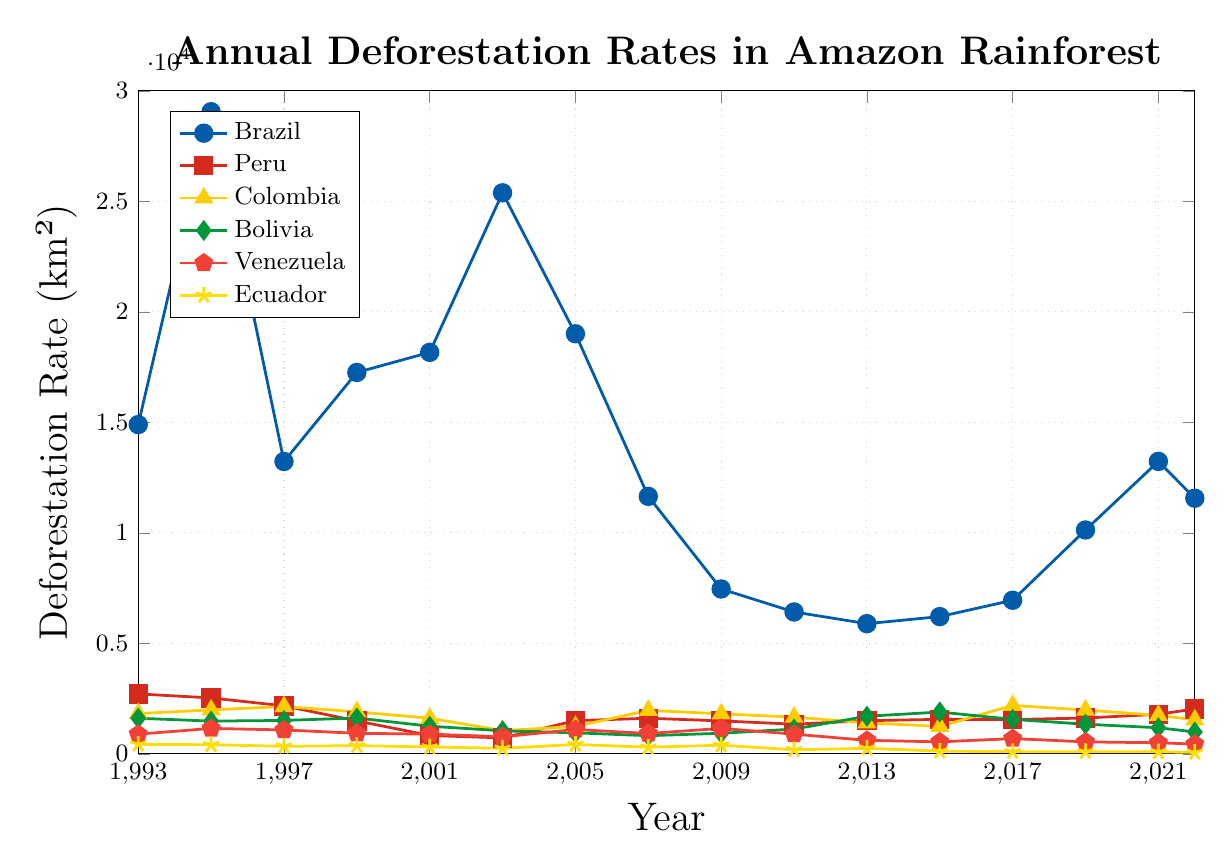Which country had the highest deforestation rate in 2003? Look at the data points for 2003 and compare them. Brazil has the highest deforestation rate, which is above 25000 km².
Answer: Brazil Which years did Brazil have a higher deforestation rate than 20000 km²? Examine the Brazil data points and pick the years where deforestation is greater than 20000 km². These years are 1995, 2003, and 2005.
Answer: 1995, 2003, 2005 What is the average deforestation rate in Peru from 1993 to 2022? Sum the deforestation rates in Peru for all the years and then divide by the number of years. Total sum: 26960. Number of years: 16. Average = 26960 / 16.
Answer: 1685 Which country experienced the most significant decrease in deforestation rate between 1995 and 2022? Check the data points for each country in 1995 and 2022 and calculate the decrease. Ecuador decreased from 410 km² in 1995 to 62 km² in 2022, the most significant drop by 348 km².
Answer: Ecuador In which year did Colombia's deforestation rate peak? Look at the Colombia data points and identify the year with the highest value. The peak is at 2190 km² in 2017.
Answer: 2017 Compare the deforestation rates of Venezuela and Ecuador in 2011. Which country had a lower rate? Refer to the data points of Venezuela and Ecuador in 2011. Venezuela has 890 km² and Ecuador has 180 km², so Ecuador has a lower rate.
Answer: Ecuador Considering the data of Peru, did its deforestation rate ever increase two consecutive measurement periods? Observe the trend of Peru data points, marking two consecutive increases. Peru showed increases in 1999-2001 (830 to 720) and 2013-2015 (1500 to 1560).
Answer: Yes Which country had the smallest fluctuation in deforestation rate over the period, considering the visual plot? Observe the consistency of the lines. Ecuador shows the smallest fluctuations, maintaining relatively low and stable rates across the years.
Answer: Ecuador What is the combined deforestation rate of Bolivia and Venezuela in 2017? Add together the deforestation rates of Bolivia and Venezuela for 2017. Bolivia: 1560, Venezuela: 690. Total is 1560 + 690.
Answer: 2250 Identify the trend of deforestation rate in Brazil from 2005 to 2022. Is it generally increasing, decreasing, or fluctuating? Look at the Brazil data points from 2005 to 2022. There is a general decreasing trend until 2009, followed by fluctuation with an increase towards 2022.
Answer: Fluctuating 